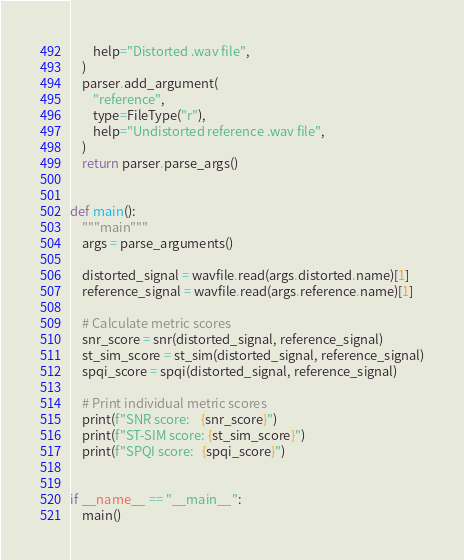Convert code to text. <code><loc_0><loc_0><loc_500><loc_500><_Python_>        help="Distorted .wav file",
    )
    parser.add_argument(
        "reference",
        type=FileType("r"),
        help="Undistorted reference .wav file",
    )
    return parser.parse_args()


def main():
    """main"""
    args = parse_arguments()

    distorted_signal = wavfile.read(args.distorted.name)[1]
    reference_signal = wavfile.read(args.reference.name)[1]

    # Calculate metric scores
    snr_score = snr(distorted_signal, reference_signal)
    st_sim_score = st_sim(distorted_signal, reference_signal)
    spqi_score = spqi(distorted_signal, reference_signal)

    # Print individual metric scores
    print(f"SNR score:    {snr_score}")
    print(f"ST-SIM score: {st_sim_score}")
    print(f"SPQI score:   {spqi_score}")


if __name__ == "__main__":
    main()
</code> 